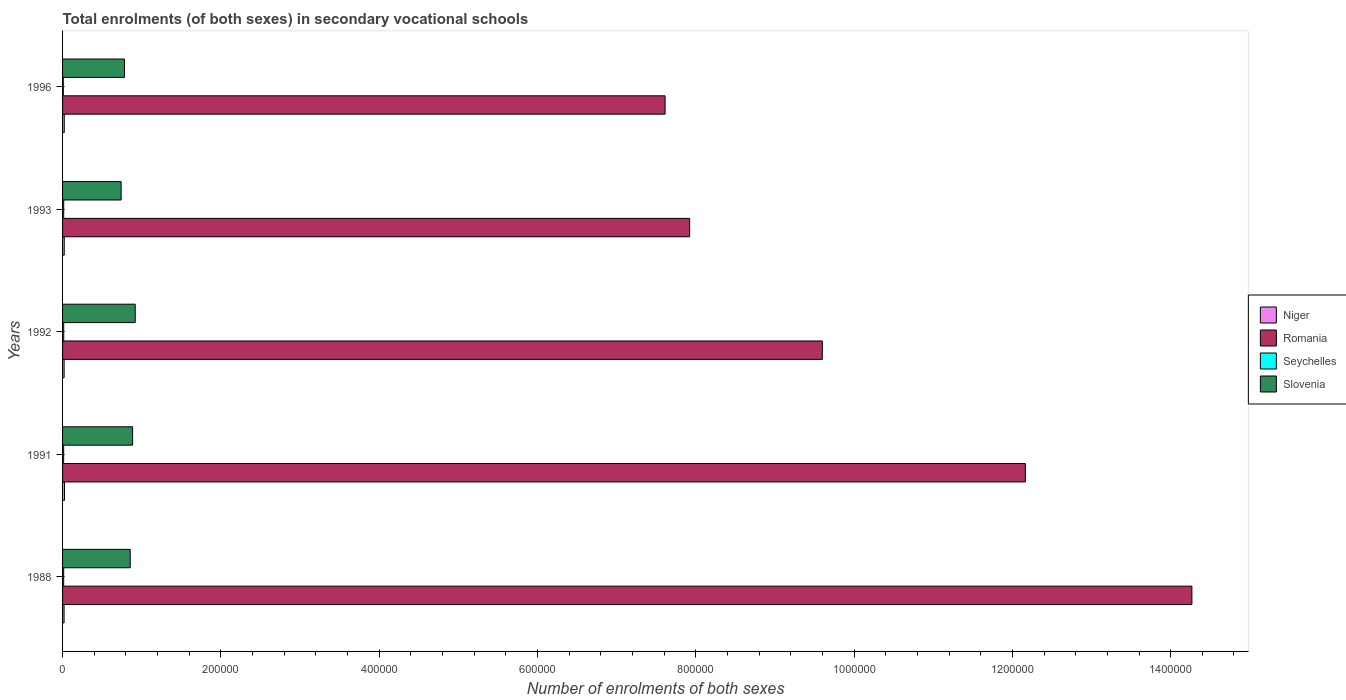How many different coloured bars are there?
Provide a succinct answer. 4. How many groups of bars are there?
Offer a terse response. 5. Are the number of bars per tick equal to the number of legend labels?
Keep it short and to the point. Yes. How many bars are there on the 1st tick from the top?
Ensure brevity in your answer.  4. How many bars are there on the 3rd tick from the bottom?
Provide a short and direct response. 4. What is the label of the 3rd group of bars from the top?
Your answer should be very brief. 1992. In how many cases, is the number of bars for a given year not equal to the number of legend labels?
Ensure brevity in your answer.  0. What is the number of enrolments in secondary schools in Seychelles in 1992?
Keep it short and to the point. 1456. Across all years, what is the maximum number of enrolments in secondary schools in Romania?
Provide a short and direct response. 1.43e+06. Across all years, what is the minimum number of enrolments in secondary schools in Slovenia?
Your answer should be very brief. 7.40e+04. In which year was the number of enrolments in secondary schools in Niger maximum?
Your answer should be very brief. 1991. In which year was the number of enrolments in secondary schools in Romania minimum?
Give a very brief answer. 1996. What is the total number of enrolments in secondary schools in Slovenia in the graph?
Your response must be concise. 4.18e+05. What is the difference between the number of enrolments in secondary schools in Slovenia in 1992 and that in 1996?
Offer a terse response. 1.35e+04. What is the difference between the number of enrolments in secondary schools in Romania in 1993 and the number of enrolments in secondary schools in Niger in 1991?
Provide a short and direct response. 7.90e+05. What is the average number of enrolments in secondary schools in Niger per year?
Provide a short and direct response. 2111.4. In the year 1992, what is the difference between the number of enrolments in secondary schools in Slovenia and number of enrolments in secondary schools in Niger?
Provide a short and direct response. 8.98e+04. In how many years, is the number of enrolments in secondary schools in Romania greater than 560000 ?
Your answer should be very brief. 5. What is the ratio of the number of enrolments in secondary schools in Niger in 1991 to that in 1993?
Offer a terse response. 1.15. What is the difference between the highest and the second highest number of enrolments in secondary schools in Romania?
Your answer should be very brief. 2.10e+05. What is the difference between the highest and the lowest number of enrolments in secondary schools in Seychelles?
Keep it short and to the point. 508. In how many years, is the number of enrolments in secondary schools in Seychelles greater than the average number of enrolments in secondary schools in Seychelles taken over all years?
Your answer should be compact. 4. Is it the case that in every year, the sum of the number of enrolments in secondary schools in Slovenia and number of enrolments in secondary schools in Romania is greater than the sum of number of enrolments in secondary schools in Seychelles and number of enrolments in secondary schools in Niger?
Your answer should be very brief. Yes. What does the 3rd bar from the top in 1996 represents?
Provide a succinct answer. Romania. What does the 3rd bar from the bottom in 1992 represents?
Ensure brevity in your answer.  Seychelles. Are all the bars in the graph horizontal?
Provide a short and direct response. Yes. How many years are there in the graph?
Provide a succinct answer. 5. Does the graph contain any zero values?
Offer a very short reply. No. How many legend labels are there?
Offer a very short reply. 4. What is the title of the graph?
Offer a terse response. Total enrolments (of both sexes) in secondary vocational schools. Does "Euro area" appear as one of the legend labels in the graph?
Your response must be concise. No. What is the label or title of the X-axis?
Your answer should be compact. Number of enrolments of both sexes. What is the Number of enrolments of both sexes of Niger in 1988?
Your answer should be very brief. 1916. What is the Number of enrolments of both sexes in Romania in 1988?
Your answer should be compact. 1.43e+06. What is the Number of enrolments of both sexes of Seychelles in 1988?
Keep it short and to the point. 1405. What is the Number of enrolments of both sexes in Slovenia in 1988?
Your response must be concise. 8.54e+04. What is the Number of enrolments of both sexes of Niger in 1991?
Keep it short and to the point. 2421. What is the Number of enrolments of both sexes in Romania in 1991?
Offer a terse response. 1.22e+06. What is the Number of enrolments of both sexes in Seychelles in 1991?
Your response must be concise. 1378. What is the Number of enrolments of both sexes of Slovenia in 1991?
Provide a short and direct response. 8.85e+04. What is the Number of enrolments of both sexes of Niger in 1992?
Provide a short and direct response. 1972. What is the Number of enrolments of both sexes in Romania in 1992?
Your response must be concise. 9.60e+05. What is the Number of enrolments of both sexes of Seychelles in 1992?
Provide a short and direct response. 1456. What is the Number of enrolments of both sexes in Slovenia in 1992?
Your answer should be very brief. 9.18e+04. What is the Number of enrolments of both sexes of Niger in 1993?
Provide a short and direct response. 2110. What is the Number of enrolments of both sexes in Romania in 1993?
Ensure brevity in your answer.  7.92e+05. What is the Number of enrolments of both sexes in Seychelles in 1993?
Your answer should be compact. 1428. What is the Number of enrolments of both sexes of Slovenia in 1993?
Make the answer very short. 7.40e+04. What is the Number of enrolments of both sexes of Niger in 1996?
Give a very brief answer. 2138. What is the Number of enrolments of both sexes of Romania in 1996?
Your answer should be compact. 7.61e+05. What is the Number of enrolments of both sexes in Seychelles in 1996?
Your response must be concise. 948. What is the Number of enrolments of both sexes of Slovenia in 1996?
Make the answer very short. 7.83e+04. Across all years, what is the maximum Number of enrolments of both sexes of Niger?
Your answer should be very brief. 2421. Across all years, what is the maximum Number of enrolments of both sexes of Romania?
Your answer should be very brief. 1.43e+06. Across all years, what is the maximum Number of enrolments of both sexes of Seychelles?
Your answer should be very brief. 1456. Across all years, what is the maximum Number of enrolments of both sexes in Slovenia?
Your answer should be compact. 9.18e+04. Across all years, what is the minimum Number of enrolments of both sexes of Niger?
Make the answer very short. 1916. Across all years, what is the minimum Number of enrolments of both sexes in Romania?
Your answer should be compact. 7.61e+05. Across all years, what is the minimum Number of enrolments of both sexes of Seychelles?
Offer a very short reply. 948. Across all years, what is the minimum Number of enrolments of both sexes in Slovenia?
Provide a succinct answer. 7.40e+04. What is the total Number of enrolments of both sexes in Niger in the graph?
Your answer should be compact. 1.06e+04. What is the total Number of enrolments of both sexes of Romania in the graph?
Offer a terse response. 5.16e+06. What is the total Number of enrolments of both sexes of Seychelles in the graph?
Your answer should be compact. 6615. What is the total Number of enrolments of both sexes in Slovenia in the graph?
Make the answer very short. 4.18e+05. What is the difference between the Number of enrolments of both sexes of Niger in 1988 and that in 1991?
Ensure brevity in your answer.  -505. What is the difference between the Number of enrolments of both sexes in Romania in 1988 and that in 1991?
Offer a terse response. 2.10e+05. What is the difference between the Number of enrolments of both sexes of Slovenia in 1988 and that in 1991?
Make the answer very short. -3055. What is the difference between the Number of enrolments of both sexes in Niger in 1988 and that in 1992?
Your answer should be very brief. -56. What is the difference between the Number of enrolments of both sexes in Romania in 1988 and that in 1992?
Keep it short and to the point. 4.67e+05. What is the difference between the Number of enrolments of both sexes of Seychelles in 1988 and that in 1992?
Offer a terse response. -51. What is the difference between the Number of enrolments of both sexes of Slovenia in 1988 and that in 1992?
Give a very brief answer. -6353. What is the difference between the Number of enrolments of both sexes of Niger in 1988 and that in 1993?
Make the answer very short. -194. What is the difference between the Number of enrolments of both sexes of Romania in 1988 and that in 1993?
Ensure brevity in your answer.  6.35e+05. What is the difference between the Number of enrolments of both sexes in Seychelles in 1988 and that in 1993?
Offer a very short reply. -23. What is the difference between the Number of enrolments of both sexes in Slovenia in 1988 and that in 1993?
Your response must be concise. 1.14e+04. What is the difference between the Number of enrolments of both sexes of Niger in 1988 and that in 1996?
Your answer should be compact. -222. What is the difference between the Number of enrolments of both sexes of Romania in 1988 and that in 1996?
Your response must be concise. 6.66e+05. What is the difference between the Number of enrolments of both sexes of Seychelles in 1988 and that in 1996?
Offer a terse response. 457. What is the difference between the Number of enrolments of both sexes of Slovenia in 1988 and that in 1996?
Your answer should be compact. 7179. What is the difference between the Number of enrolments of both sexes in Niger in 1991 and that in 1992?
Your answer should be very brief. 449. What is the difference between the Number of enrolments of both sexes in Romania in 1991 and that in 1992?
Offer a terse response. 2.57e+05. What is the difference between the Number of enrolments of both sexes in Seychelles in 1991 and that in 1992?
Give a very brief answer. -78. What is the difference between the Number of enrolments of both sexes in Slovenia in 1991 and that in 1992?
Your response must be concise. -3298. What is the difference between the Number of enrolments of both sexes of Niger in 1991 and that in 1993?
Ensure brevity in your answer.  311. What is the difference between the Number of enrolments of both sexes of Romania in 1991 and that in 1993?
Offer a very short reply. 4.24e+05. What is the difference between the Number of enrolments of both sexes in Seychelles in 1991 and that in 1993?
Offer a terse response. -50. What is the difference between the Number of enrolments of both sexes of Slovenia in 1991 and that in 1993?
Make the answer very short. 1.45e+04. What is the difference between the Number of enrolments of both sexes of Niger in 1991 and that in 1996?
Ensure brevity in your answer.  283. What is the difference between the Number of enrolments of both sexes in Romania in 1991 and that in 1996?
Your response must be concise. 4.55e+05. What is the difference between the Number of enrolments of both sexes of Seychelles in 1991 and that in 1996?
Offer a terse response. 430. What is the difference between the Number of enrolments of both sexes of Slovenia in 1991 and that in 1996?
Ensure brevity in your answer.  1.02e+04. What is the difference between the Number of enrolments of both sexes in Niger in 1992 and that in 1993?
Provide a short and direct response. -138. What is the difference between the Number of enrolments of both sexes of Romania in 1992 and that in 1993?
Ensure brevity in your answer.  1.68e+05. What is the difference between the Number of enrolments of both sexes of Slovenia in 1992 and that in 1993?
Ensure brevity in your answer.  1.78e+04. What is the difference between the Number of enrolments of both sexes in Niger in 1992 and that in 1996?
Keep it short and to the point. -166. What is the difference between the Number of enrolments of both sexes in Romania in 1992 and that in 1996?
Your answer should be compact. 1.99e+05. What is the difference between the Number of enrolments of both sexes in Seychelles in 1992 and that in 1996?
Your answer should be very brief. 508. What is the difference between the Number of enrolments of both sexes in Slovenia in 1992 and that in 1996?
Your response must be concise. 1.35e+04. What is the difference between the Number of enrolments of both sexes of Niger in 1993 and that in 1996?
Offer a very short reply. -28. What is the difference between the Number of enrolments of both sexes of Romania in 1993 and that in 1996?
Make the answer very short. 3.10e+04. What is the difference between the Number of enrolments of both sexes of Seychelles in 1993 and that in 1996?
Provide a short and direct response. 480. What is the difference between the Number of enrolments of both sexes in Slovenia in 1993 and that in 1996?
Your answer should be compact. -4257. What is the difference between the Number of enrolments of both sexes in Niger in 1988 and the Number of enrolments of both sexes in Romania in 1991?
Offer a very short reply. -1.21e+06. What is the difference between the Number of enrolments of both sexes in Niger in 1988 and the Number of enrolments of both sexes in Seychelles in 1991?
Offer a very short reply. 538. What is the difference between the Number of enrolments of both sexes in Niger in 1988 and the Number of enrolments of both sexes in Slovenia in 1991?
Your answer should be very brief. -8.66e+04. What is the difference between the Number of enrolments of both sexes of Romania in 1988 and the Number of enrolments of both sexes of Seychelles in 1991?
Give a very brief answer. 1.43e+06. What is the difference between the Number of enrolments of both sexes of Romania in 1988 and the Number of enrolments of both sexes of Slovenia in 1991?
Provide a short and direct response. 1.34e+06. What is the difference between the Number of enrolments of both sexes of Seychelles in 1988 and the Number of enrolments of both sexes of Slovenia in 1991?
Offer a terse response. -8.71e+04. What is the difference between the Number of enrolments of both sexes in Niger in 1988 and the Number of enrolments of both sexes in Romania in 1992?
Keep it short and to the point. -9.58e+05. What is the difference between the Number of enrolments of both sexes in Niger in 1988 and the Number of enrolments of both sexes in Seychelles in 1992?
Your answer should be compact. 460. What is the difference between the Number of enrolments of both sexes in Niger in 1988 and the Number of enrolments of both sexes in Slovenia in 1992?
Give a very brief answer. -8.99e+04. What is the difference between the Number of enrolments of both sexes in Romania in 1988 and the Number of enrolments of both sexes in Seychelles in 1992?
Your answer should be compact. 1.43e+06. What is the difference between the Number of enrolments of both sexes of Romania in 1988 and the Number of enrolments of both sexes of Slovenia in 1992?
Give a very brief answer. 1.34e+06. What is the difference between the Number of enrolments of both sexes in Seychelles in 1988 and the Number of enrolments of both sexes in Slovenia in 1992?
Your answer should be compact. -9.04e+04. What is the difference between the Number of enrolments of both sexes of Niger in 1988 and the Number of enrolments of both sexes of Romania in 1993?
Make the answer very short. -7.90e+05. What is the difference between the Number of enrolments of both sexes in Niger in 1988 and the Number of enrolments of both sexes in Seychelles in 1993?
Your answer should be very brief. 488. What is the difference between the Number of enrolments of both sexes in Niger in 1988 and the Number of enrolments of both sexes in Slovenia in 1993?
Give a very brief answer. -7.21e+04. What is the difference between the Number of enrolments of both sexes in Romania in 1988 and the Number of enrolments of both sexes in Seychelles in 1993?
Offer a very short reply. 1.43e+06. What is the difference between the Number of enrolments of both sexes of Romania in 1988 and the Number of enrolments of both sexes of Slovenia in 1993?
Your response must be concise. 1.35e+06. What is the difference between the Number of enrolments of both sexes of Seychelles in 1988 and the Number of enrolments of both sexes of Slovenia in 1993?
Offer a terse response. -7.26e+04. What is the difference between the Number of enrolments of both sexes in Niger in 1988 and the Number of enrolments of both sexes in Romania in 1996?
Provide a succinct answer. -7.59e+05. What is the difference between the Number of enrolments of both sexes of Niger in 1988 and the Number of enrolments of both sexes of Seychelles in 1996?
Your answer should be very brief. 968. What is the difference between the Number of enrolments of both sexes in Niger in 1988 and the Number of enrolments of both sexes in Slovenia in 1996?
Make the answer very short. -7.64e+04. What is the difference between the Number of enrolments of both sexes of Romania in 1988 and the Number of enrolments of both sexes of Seychelles in 1996?
Ensure brevity in your answer.  1.43e+06. What is the difference between the Number of enrolments of both sexes of Romania in 1988 and the Number of enrolments of both sexes of Slovenia in 1996?
Offer a very short reply. 1.35e+06. What is the difference between the Number of enrolments of both sexes in Seychelles in 1988 and the Number of enrolments of both sexes in Slovenia in 1996?
Make the answer very short. -7.69e+04. What is the difference between the Number of enrolments of both sexes in Niger in 1991 and the Number of enrolments of both sexes in Romania in 1992?
Your answer should be very brief. -9.57e+05. What is the difference between the Number of enrolments of both sexes of Niger in 1991 and the Number of enrolments of both sexes of Seychelles in 1992?
Your answer should be very brief. 965. What is the difference between the Number of enrolments of both sexes in Niger in 1991 and the Number of enrolments of both sexes in Slovenia in 1992?
Your response must be concise. -8.94e+04. What is the difference between the Number of enrolments of both sexes of Romania in 1991 and the Number of enrolments of both sexes of Seychelles in 1992?
Ensure brevity in your answer.  1.21e+06. What is the difference between the Number of enrolments of both sexes in Romania in 1991 and the Number of enrolments of both sexes in Slovenia in 1992?
Keep it short and to the point. 1.12e+06. What is the difference between the Number of enrolments of both sexes in Seychelles in 1991 and the Number of enrolments of both sexes in Slovenia in 1992?
Give a very brief answer. -9.04e+04. What is the difference between the Number of enrolments of both sexes in Niger in 1991 and the Number of enrolments of both sexes in Romania in 1993?
Your answer should be compact. -7.90e+05. What is the difference between the Number of enrolments of both sexes in Niger in 1991 and the Number of enrolments of both sexes in Seychelles in 1993?
Your answer should be very brief. 993. What is the difference between the Number of enrolments of both sexes of Niger in 1991 and the Number of enrolments of both sexes of Slovenia in 1993?
Offer a terse response. -7.16e+04. What is the difference between the Number of enrolments of both sexes of Romania in 1991 and the Number of enrolments of both sexes of Seychelles in 1993?
Your answer should be compact. 1.22e+06. What is the difference between the Number of enrolments of both sexes in Romania in 1991 and the Number of enrolments of both sexes in Slovenia in 1993?
Ensure brevity in your answer.  1.14e+06. What is the difference between the Number of enrolments of both sexes of Seychelles in 1991 and the Number of enrolments of both sexes of Slovenia in 1993?
Ensure brevity in your answer.  -7.26e+04. What is the difference between the Number of enrolments of both sexes of Niger in 1991 and the Number of enrolments of both sexes of Romania in 1996?
Your response must be concise. -7.59e+05. What is the difference between the Number of enrolments of both sexes in Niger in 1991 and the Number of enrolments of both sexes in Seychelles in 1996?
Give a very brief answer. 1473. What is the difference between the Number of enrolments of both sexes in Niger in 1991 and the Number of enrolments of both sexes in Slovenia in 1996?
Make the answer very short. -7.58e+04. What is the difference between the Number of enrolments of both sexes in Romania in 1991 and the Number of enrolments of both sexes in Seychelles in 1996?
Make the answer very short. 1.22e+06. What is the difference between the Number of enrolments of both sexes of Romania in 1991 and the Number of enrolments of both sexes of Slovenia in 1996?
Give a very brief answer. 1.14e+06. What is the difference between the Number of enrolments of both sexes in Seychelles in 1991 and the Number of enrolments of both sexes in Slovenia in 1996?
Offer a terse response. -7.69e+04. What is the difference between the Number of enrolments of both sexes in Niger in 1992 and the Number of enrolments of both sexes in Romania in 1993?
Offer a terse response. -7.90e+05. What is the difference between the Number of enrolments of both sexes in Niger in 1992 and the Number of enrolments of both sexes in Seychelles in 1993?
Your response must be concise. 544. What is the difference between the Number of enrolments of both sexes in Niger in 1992 and the Number of enrolments of both sexes in Slovenia in 1993?
Keep it short and to the point. -7.20e+04. What is the difference between the Number of enrolments of both sexes in Romania in 1992 and the Number of enrolments of both sexes in Seychelles in 1993?
Ensure brevity in your answer.  9.58e+05. What is the difference between the Number of enrolments of both sexes in Romania in 1992 and the Number of enrolments of both sexes in Slovenia in 1993?
Offer a terse response. 8.86e+05. What is the difference between the Number of enrolments of both sexes of Seychelles in 1992 and the Number of enrolments of both sexes of Slovenia in 1993?
Give a very brief answer. -7.26e+04. What is the difference between the Number of enrolments of both sexes of Niger in 1992 and the Number of enrolments of both sexes of Romania in 1996?
Your answer should be very brief. -7.59e+05. What is the difference between the Number of enrolments of both sexes in Niger in 1992 and the Number of enrolments of both sexes in Seychelles in 1996?
Your answer should be very brief. 1024. What is the difference between the Number of enrolments of both sexes of Niger in 1992 and the Number of enrolments of both sexes of Slovenia in 1996?
Provide a succinct answer. -7.63e+04. What is the difference between the Number of enrolments of both sexes in Romania in 1992 and the Number of enrolments of both sexes in Seychelles in 1996?
Offer a very short reply. 9.59e+05. What is the difference between the Number of enrolments of both sexes of Romania in 1992 and the Number of enrolments of both sexes of Slovenia in 1996?
Make the answer very short. 8.82e+05. What is the difference between the Number of enrolments of both sexes of Seychelles in 1992 and the Number of enrolments of both sexes of Slovenia in 1996?
Your answer should be compact. -7.68e+04. What is the difference between the Number of enrolments of both sexes of Niger in 1993 and the Number of enrolments of both sexes of Romania in 1996?
Give a very brief answer. -7.59e+05. What is the difference between the Number of enrolments of both sexes in Niger in 1993 and the Number of enrolments of both sexes in Seychelles in 1996?
Ensure brevity in your answer.  1162. What is the difference between the Number of enrolments of both sexes in Niger in 1993 and the Number of enrolments of both sexes in Slovenia in 1996?
Offer a very short reply. -7.62e+04. What is the difference between the Number of enrolments of both sexes of Romania in 1993 and the Number of enrolments of both sexes of Seychelles in 1996?
Make the answer very short. 7.91e+05. What is the difference between the Number of enrolments of both sexes of Romania in 1993 and the Number of enrolments of both sexes of Slovenia in 1996?
Make the answer very short. 7.14e+05. What is the difference between the Number of enrolments of both sexes in Seychelles in 1993 and the Number of enrolments of both sexes in Slovenia in 1996?
Provide a succinct answer. -7.68e+04. What is the average Number of enrolments of both sexes of Niger per year?
Keep it short and to the point. 2111.4. What is the average Number of enrolments of both sexes in Romania per year?
Give a very brief answer. 1.03e+06. What is the average Number of enrolments of both sexes in Seychelles per year?
Offer a very short reply. 1323. What is the average Number of enrolments of both sexes in Slovenia per year?
Offer a terse response. 8.36e+04. In the year 1988, what is the difference between the Number of enrolments of both sexes of Niger and Number of enrolments of both sexes of Romania?
Your response must be concise. -1.42e+06. In the year 1988, what is the difference between the Number of enrolments of both sexes of Niger and Number of enrolments of both sexes of Seychelles?
Your response must be concise. 511. In the year 1988, what is the difference between the Number of enrolments of both sexes of Niger and Number of enrolments of both sexes of Slovenia?
Provide a succinct answer. -8.35e+04. In the year 1988, what is the difference between the Number of enrolments of both sexes of Romania and Number of enrolments of both sexes of Seychelles?
Your answer should be compact. 1.43e+06. In the year 1988, what is the difference between the Number of enrolments of both sexes in Romania and Number of enrolments of both sexes in Slovenia?
Offer a terse response. 1.34e+06. In the year 1988, what is the difference between the Number of enrolments of both sexes in Seychelles and Number of enrolments of both sexes in Slovenia?
Your answer should be very brief. -8.40e+04. In the year 1991, what is the difference between the Number of enrolments of both sexes of Niger and Number of enrolments of both sexes of Romania?
Give a very brief answer. -1.21e+06. In the year 1991, what is the difference between the Number of enrolments of both sexes in Niger and Number of enrolments of both sexes in Seychelles?
Offer a very short reply. 1043. In the year 1991, what is the difference between the Number of enrolments of both sexes of Niger and Number of enrolments of both sexes of Slovenia?
Keep it short and to the point. -8.61e+04. In the year 1991, what is the difference between the Number of enrolments of both sexes of Romania and Number of enrolments of both sexes of Seychelles?
Make the answer very short. 1.22e+06. In the year 1991, what is the difference between the Number of enrolments of both sexes in Romania and Number of enrolments of both sexes in Slovenia?
Make the answer very short. 1.13e+06. In the year 1991, what is the difference between the Number of enrolments of both sexes of Seychelles and Number of enrolments of both sexes of Slovenia?
Ensure brevity in your answer.  -8.71e+04. In the year 1992, what is the difference between the Number of enrolments of both sexes of Niger and Number of enrolments of both sexes of Romania?
Give a very brief answer. -9.58e+05. In the year 1992, what is the difference between the Number of enrolments of both sexes of Niger and Number of enrolments of both sexes of Seychelles?
Provide a short and direct response. 516. In the year 1992, what is the difference between the Number of enrolments of both sexes of Niger and Number of enrolments of both sexes of Slovenia?
Ensure brevity in your answer.  -8.98e+04. In the year 1992, what is the difference between the Number of enrolments of both sexes of Romania and Number of enrolments of both sexes of Seychelles?
Ensure brevity in your answer.  9.58e+05. In the year 1992, what is the difference between the Number of enrolments of both sexes of Romania and Number of enrolments of both sexes of Slovenia?
Provide a succinct answer. 8.68e+05. In the year 1992, what is the difference between the Number of enrolments of both sexes in Seychelles and Number of enrolments of both sexes in Slovenia?
Make the answer very short. -9.03e+04. In the year 1993, what is the difference between the Number of enrolments of both sexes of Niger and Number of enrolments of both sexes of Romania?
Your response must be concise. -7.90e+05. In the year 1993, what is the difference between the Number of enrolments of both sexes in Niger and Number of enrolments of both sexes in Seychelles?
Offer a terse response. 682. In the year 1993, what is the difference between the Number of enrolments of both sexes of Niger and Number of enrolments of both sexes of Slovenia?
Offer a terse response. -7.19e+04. In the year 1993, what is the difference between the Number of enrolments of both sexes in Romania and Number of enrolments of both sexes in Seychelles?
Provide a succinct answer. 7.91e+05. In the year 1993, what is the difference between the Number of enrolments of both sexes in Romania and Number of enrolments of both sexes in Slovenia?
Offer a terse response. 7.18e+05. In the year 1993, what is the difference between the Number of enrolments of both sexes of Seychelles and Number of enrolments of both sexes of Slovenia?
Offer a very short reply. -7.26e+04. In the year 1996, what is the difference between the Number of enrolments of both sexes in Niger and Number of enrolments of both sexes in Romania?
Keep it short and to the point. -7.59e+05. In the year 1996, what is the difference between the Number of enrolments of both sexes of Niger and Number of enrolments of both sexes of Seychelles?
Offer a terse response. 1190. In the year 1996, what is the difference between the Number of enrolments of both sexes in Niger and Number of enrolments of both sexes in Slovenia?
Give a very brief answer. -7.61e+04. In the year 1996, what is the difference between the Number of enrolments of both sexes of Romania and Number of enrolments of both sexes of Seychelles?
Your answer should be compact. 7.60e+05. In the year 1996, what is the difference between the Number of enrolments of both sexes in Romania and Number of enrolments of both sexes in Slovenia?
Your answer should be compact. 6.83e+05. In the year 1996, what is the difference between the Number of enrolments of both sexes in Seychelles and Number of enrolments of both sexes in Slovenia?
Your answer should be compact. -7.73e+04. What is the ratio of the Number of enrolments of both sexes of Niger in 1988 to that in 1991?
Make the answer very short. 0.79. What is the ratio of the Number of enrolments of both sexes of Romania in 1988 to that in 1991?
Provide a succinct answer. 1.17. What is the ratio of the Number of enrolments of both sexes of Seychelles in 1988 to that in 1991?
Give a very brief answer. 1.02. What is the ratio of the Number of enrolments of both sexes of Slovenia in 1988 to that in 1991?
Provide a short and direct response. 0.97. What is the ratio of the Number of enrolments of both sexes in Niger in 1988 to that in 1992?
Keep it short and to the point. 0.97. What is the ratio of the Number of enrolments of both sexes in Romania in 1988 to that in 1992?
Your response must be concise. 1.49. What is the ratio of the Number of enrolments of both sexes of Seychelles in 1988 to that in 1992?
Your answer should be very brief. 0.96. What is the ratio of the Number of enrolments of both sexes of Slovenia in 1988 to that in 1992?
Your answer should be very brief. 0.93. What is the ratio of the Number of enrolments of both sexes of Niger in 1988 to that in 1993?
Provide a short and direct response. 0.91. What is the ratio of the Number of enrolments of both sexes of Romania in 1988 to that in 1993?
Offer a terse response. 1.8. What is the ratio of the Number of enrolments of both sexes of Seychelles in 1988 to that in 1993?
Your response must be concise. 0.98. What is the ratio of the Number of enrolments of both sexes in Slovenia in 1988 to that in 1993?
Your answer should be very brief. 1.15. What is the ratio of the Number of enrolments of both sexes of Niger in 1988 to that in 1996?
Provide a short and direct response. 0.9. What is the ratio of the Number of enrolments of both sexes in Romania in 1988 to that in 1996?
Keep it short and to the point. 1.87. What is the ratio of the Number of enrolments of both sexes in Seychelles in 1988 to that in 1996?
Make the answer very short. 1.48. What is the ratio of the Number of enrolments of both sexes in Slovenia in 1988 to that in 1996?
Provide a succinct answer. 1.09. What is the ratio of the Number of enrolments of both sexes of Niger in 1991 to that in 1992?
Your answer should be compact. 1.23. What is the ratio of the Number of enrolments of both sexes of Romania in 1991 to that in 1992?
Give a very brief answer. 1.27. What is the ratio of the Number of enrolments of both sexes of Seychelles in 1991 to that in 1992?
Give a very brief answer. 0.95. What is the ratio of the Number of enrolments of both sexes of Slovenia in 1991 to that in 1992?
Keep it short and to the point. 0.96. What is the ratio of the Number of enrolments of both sexes of Niger in 1991 to that in 1993?
Offer a very short reply. 1.15. What is the ratio of the Number of enrolments of both sexes in Romania in 1991 to that in 1993?
Provide a short and direct response. 1.54. What is the ratio of the Number of enrolments of both sexes of Slovenia in 1991 to that in 1993?
Make the answer very short. 1.2. What is the ratio of the Number of enrolments of both sexes in Niger in 1991 to that in 1996?
Provide a short and direct response. 1.13. What is the ratio of the Number of enrolments of both sexes in Romania in 1991 to that in 1996?
Keep it short and to the point. 1.6. What is the ratio of the Number of enrolments of both sexes in Seychelles in 1991 to that in 1996?
Your response must be concise. 1.45. What is the ratio of the Number of enrolments of both sexes in Slovenia in 1991 to that in 1996?
Ensure brevity in your answer.  1.13. What is the ratio of the Number of enrolments of both sexes in Niger in 1992 to that in 1993?
Your answer should be very brief. 0.93. What is the ratio of the Number of enrolments of both sexes of Romania in 1992 to that in 1993?
Offer a very short reply. 1.21. What is the ratio of the Number of enrolments of both sexes of Seychelles in 1992 to that in 1993?
Offer a very short reply. 1.02. What is the ratio of the Number of enrolments of both sexes in Slovenia in 1992 to that in 1993?
Provide a short and direct response. 1.24. What is the ratio of the Number of enrolments of both sexes in Niger in 1992 to that in 1996?
Provide a short and direct response. 0.92. What is the ratio of the Number of enrolments of both sexes in Romania in 1992 to that in 1996?
Your response must be concise. 1.26. What is the ratio of the Number of enrolments of both sexes in Seychelles in 1992 to that in 1996?
Your response must be concise. 1.54. What is the ratio of the Number of enrolments of both sexes of Slovenia in 1992 to that in 1996?
Offer a terse response. 1.17. What is the ratio of the Number of enrolments of both sexes in Niger in 1993 to that in 1996?
Give a very brief answer. 0.99. What is the ratio of the Number of enrolments of both sexes in Romania in 1993 to that in 1996?
Your answer should be compact. 1.04. What is the ratio of the Number of enrolments of both sexes of Seychelles in 1993 to that in 1996?
Your answer should be very brief. 1.51. What is the ratio of the Number of enrolments of both sexes in Slovenia in 1993 to that in 1996?
Make the answer very short. 0.95. What is the difference between the highest and the second highest Number of enrolments of both sexes of Niger?
Offer a terse response. 283. What is the difference between the highest and the second highest Number of enrolments of both sexes of Romania?
Provide a succinct answer. 2.10e+05. What is the difference between the highest and the second highest Number of enrolments of both sexes of Seychelles?
Provide a short and direct response. 28. What is the difference between the highest and the second highest Number of enrolments of both sexes of Slovenia?
Keep it short and to the point. 3298. What is the difference between the highest and the lowest Number of enrolments of both sexes of Niger?
Make the answer very short. 505. What is the difference between the highest and the lowest Number of enrolments of both sexes of Romania?
Your answer should be compact. 6.66e+05. What is the difference between the highest and the lowest Number of enrolments of both sexes of Seychelles?
Keep it short and to the point. 508. What is the difference between the highest and the lowest Number of enrolments of both sexes in Slovenia?
Give a very brief answer. 1.78e+04. 